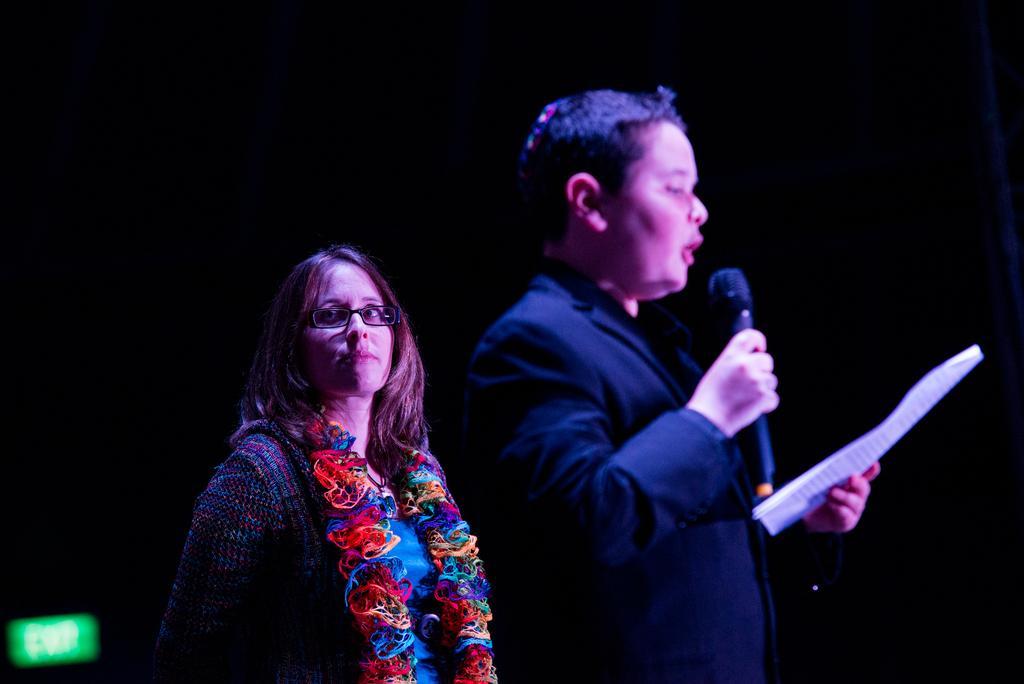In one or two sentences, can you explain what this image depicts? In this image I can see a person wearing black color dress is standing and holding a microphone and a paper in his hand. I can see another person wearing blue colored dress. I can see the black background and the green colored object to the left bottom of the image. 